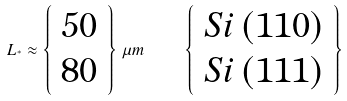<formula> <loc_0><loc_0><loc_500><loc_500>L _ { ^ { * } } \approx \left \{ \begin{array} { c } 5 0 \\ 8 0 \end{array} \right \} \, \mu m \quad \left \{ \begin{array} { c } S i \, ( 1 1 0 ) \\ S i \, ( 1 1 1 ) \end{array} \right \}</formula> 